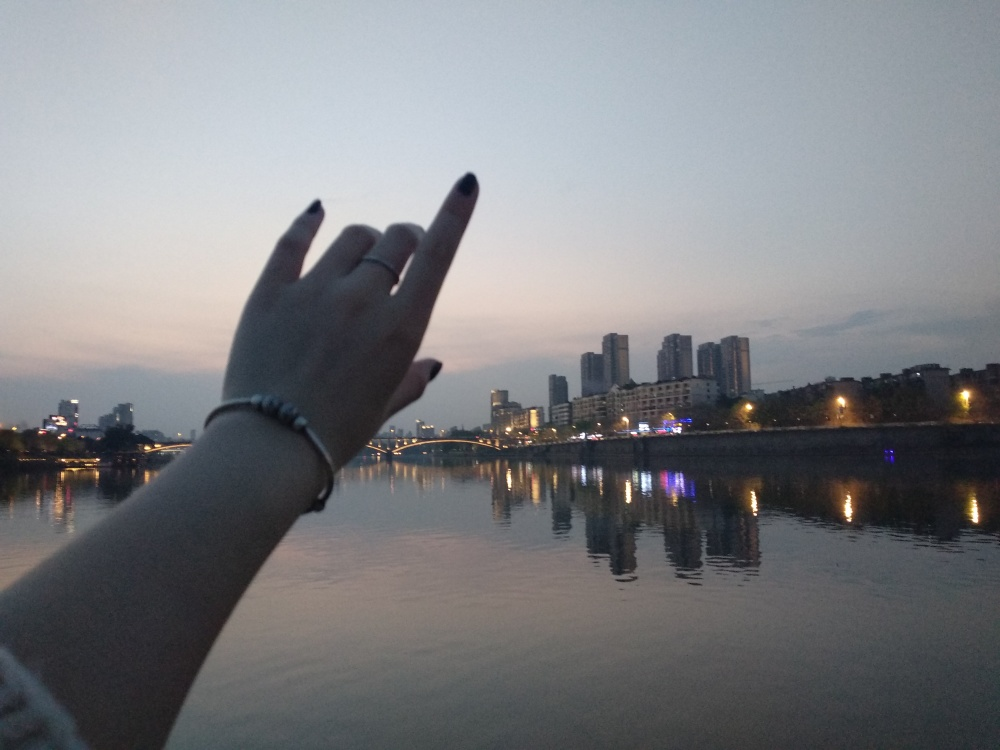What time of day does this image seem to capture, and how can you tell? The image captures the blue hour of early evening, just after sunset. You can tell by the sky's color transition from blue to purple and the city lights that have started to illuminate buildings and street lamps, while there's still enough natural light to see the surroundings clearly. 